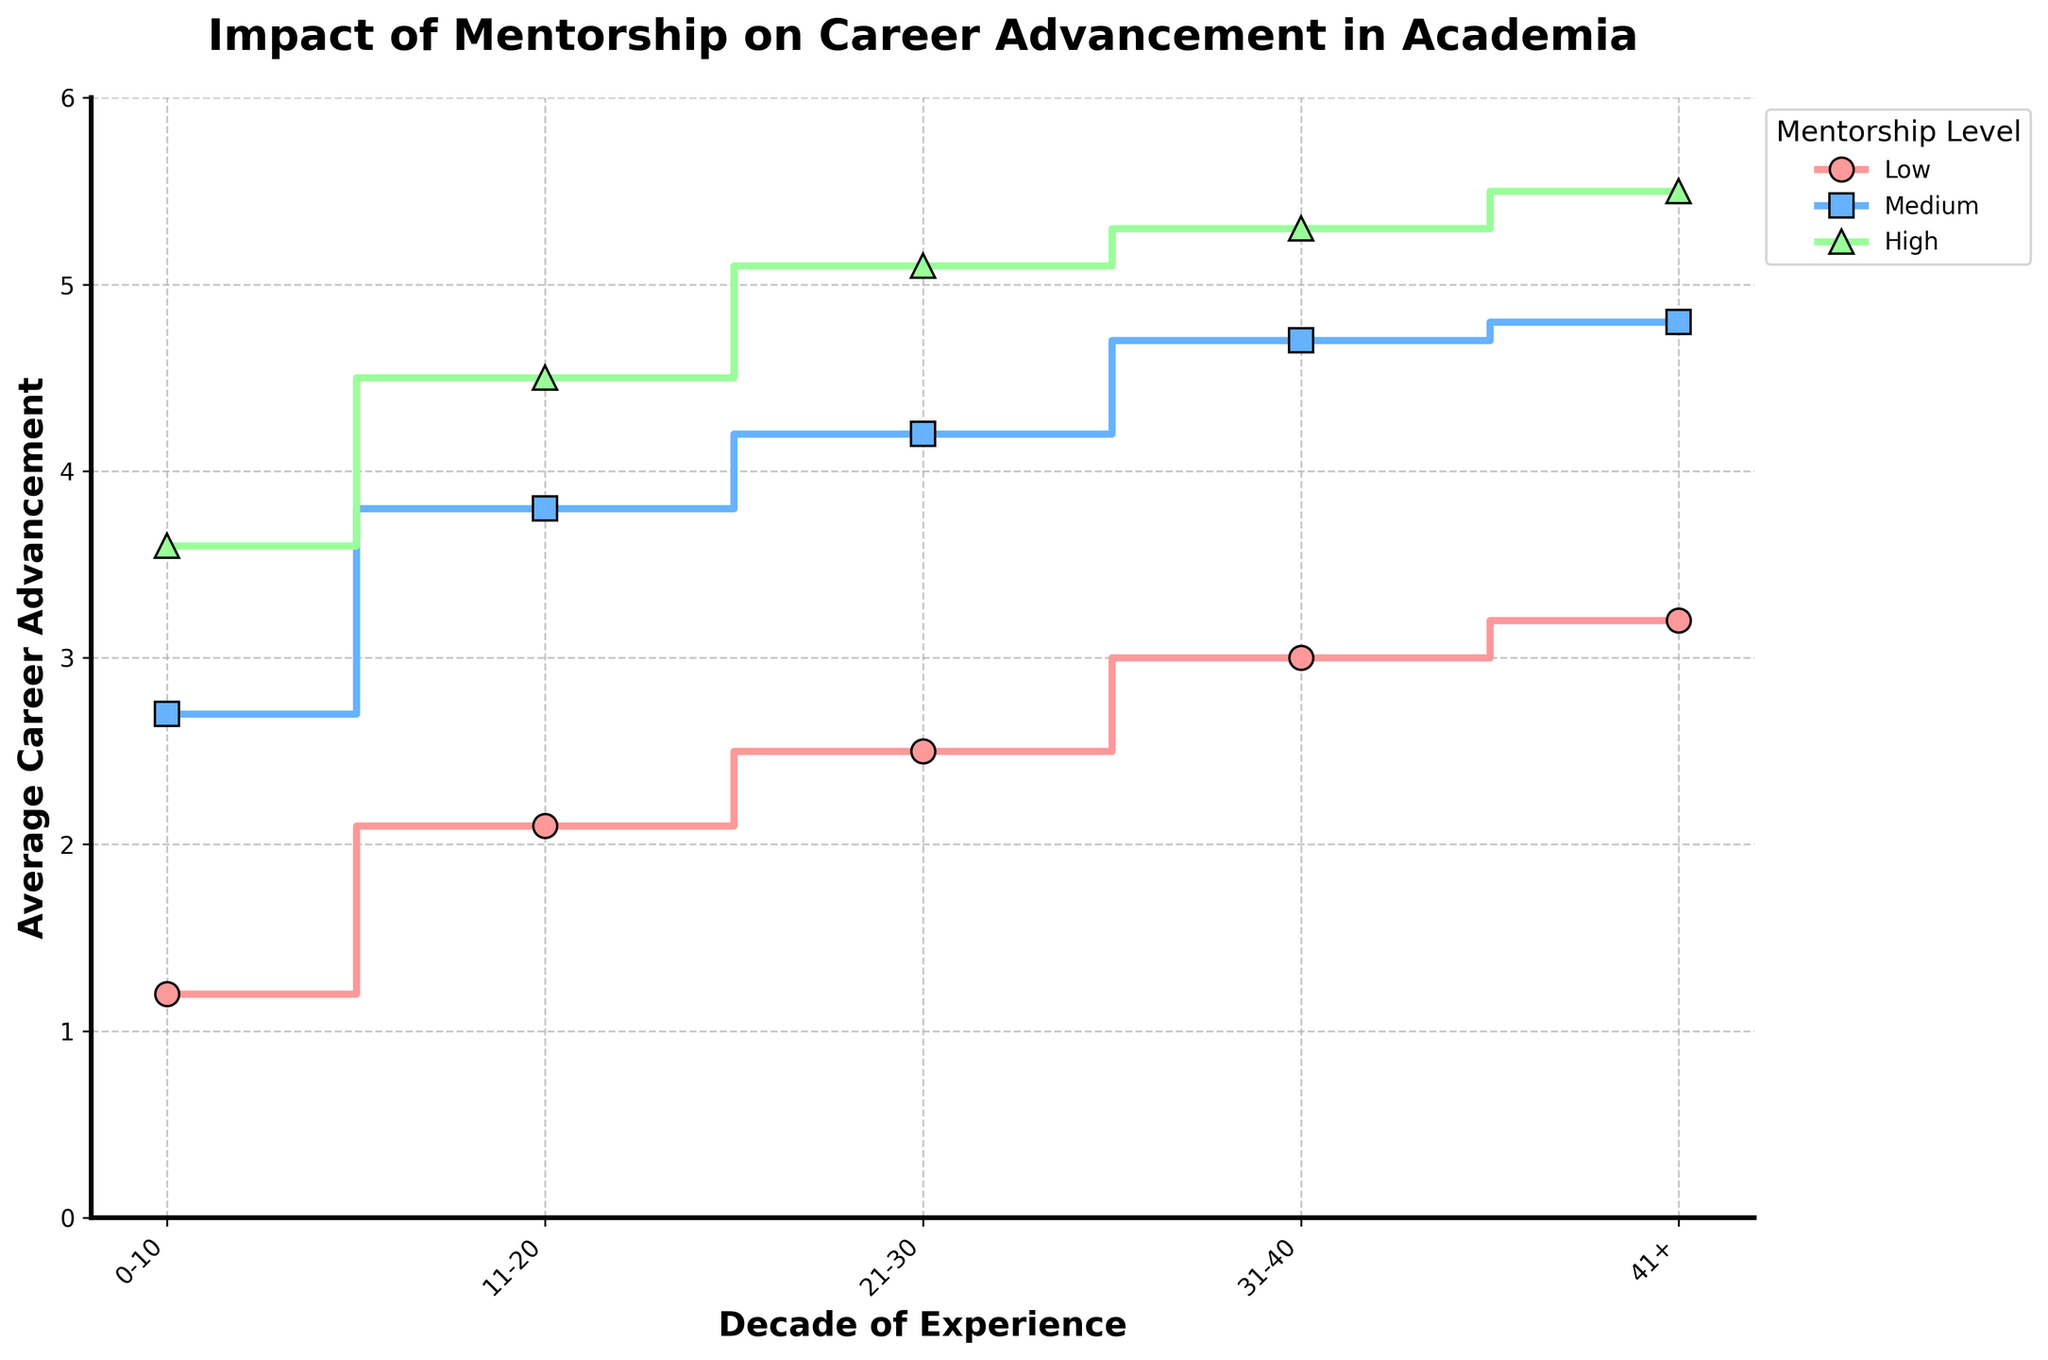What is the title of the figure? The title of the figure is prominent and located at the top of the plot.
Answer: Impact of Mentorship on Career Advancement in Academia Which decade shows the highest career advancement for high mentorship levels? Observing the trend of high mentorship levels across different decades from the plot, the highest average career advancement occurs in the "41+" decade.
Answer: 41+ How does career advancement change from low to high mentorship in the 11-20 decade? To find the change, observe the average career advancement for low and high mentorship levels within the 11-20 decade. Subtract the low level (2.1) from the high level (4.5): 4.5 - 2.1 = 2.4.
Answer: It increases by 2.4 Which mentorship level consistently shows the lowest career advancement across all decades? By examining each decade, the "low" mentorship level consistently records the lowest career advancement compared to the "medium" and "high" levels.
Answer: Low mentorship level What is the difference in average career advancement between the 0-10 and 21-30 decades for medium mentorship? Locate the medium mentorship level's average career advancement for both decades (0-10: 2.7, 21-30: 4.2). Subtract the value of the 0-10 decade from the 21-30 decade: 4.2 - 2.7 = 1.5.
Answer: 1.5 In which decade does medium mentorship achieve the highest average career advancement? The highest value for medium mentorship can be seen in the 41+ decade with an average career advancement of 4.8.
Answer: 41+ How do the career advancements in the 31-40 decade compare for low and high mentorship levels? For the decade 31-40, compare the average career advancements for low (3.0) and high (5.3) mentorship levels by simply reading the values for each from the plot.
Answer: High mentorship is higher by 2.3 How does the average career advancement change from 21-30 to 31-40 for low mentorship? Look at the average career advancement for low mentorship at both points (21-30: 2.5, 31-40: 3.0) and calculate the difference: 3.0 - 2.5 = 0.5.
Answer: It increases by 0.5 Between which two decades is there the smallest increase in average career advancement for high mentorship levels? By observing the average career advancements for high mentorship levels across all decades, find the minimal difference: 0-10 to 11-20 (3.6 to 4.5), 11-20 to 21-30 (4.5 to 5.1), and 21-30 to 31-40 (5.1 to 5.3). The smallest increase is between 21-30 and 31-40 (5.1 to 5.3), resulting in 0.2.
Answer: 21-30 to 31-40 